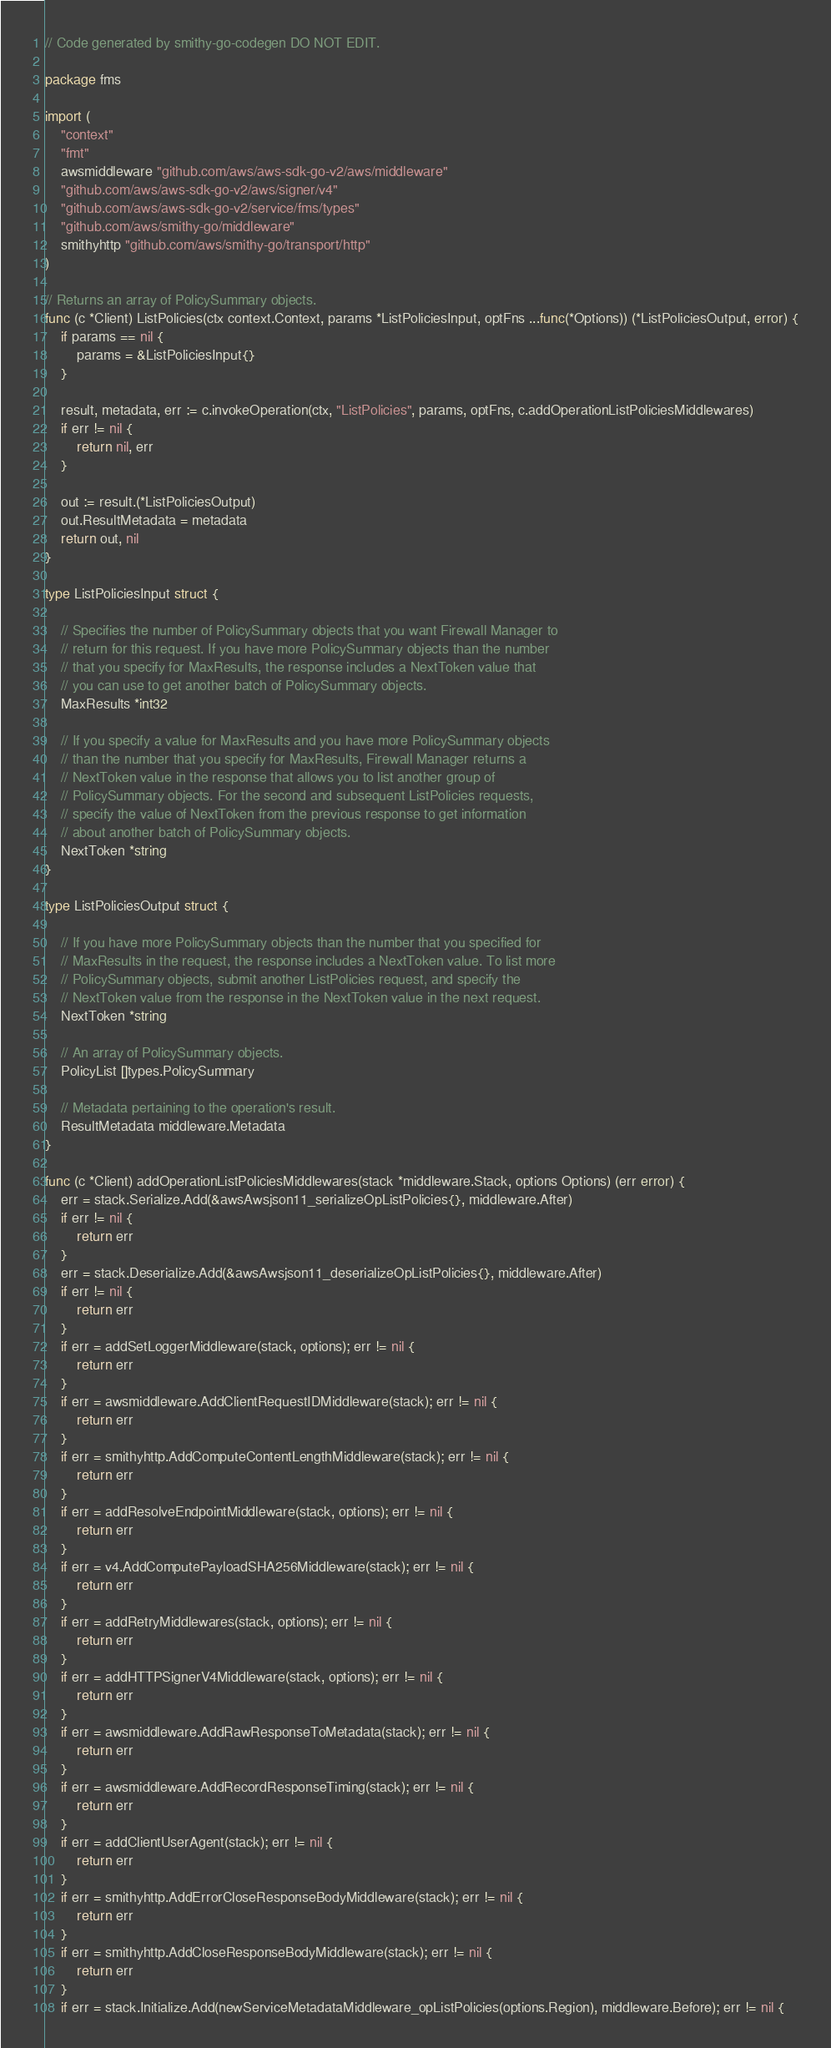<code> <loc_0><loc_0><loc_500><loc_500><_Go_>// Code generated by smithy-go-codegen DO NOT EDIT.

package fms

import (
	"context"
	"fmt"
	awsmiddleware "github.com/aws/aws-sdk-go-v2/aws/middleware"
	"github.com/aws/aws-sdk-go-v2/aws/signer/v4"
	"github.com/aws/aws-sdk-go-v2/service/fms/types"
	"github.com/aws/smithy-go/middleware"
	smithyhttp "github.com/aws/smithy-go/transport/http"
)

// Returns an array of PolicySummary objects.
func (c *Client) ListPolicies(ctx context.Context, params *ListPoliciesInput, optFns ...func(*Options)) (*ListPoliciesOutput, error) {
	if params == nil {
		params = &ListPoliciesInput{}
	}

	result, metadata, err := c.invokeOperation(ctx, "ListPolicies", params, optFns, c.addOperationListPoliciesMiddlewares)
	if err != nil {
		return nil, err
	}

	out := result.(*ListPoliciesOutput)
	out.ResultMetadata = metadata
	return out, nil
}

type ListPoliciesInput struct {

	// Specifies the number of PolicySummary objects that you want Firewall Manager to
	// return for this request. If you have more PolicySummary objects than the number
	// that you specify for MaxResults, the response includes a NextToken value that
	// you can use to get another batch of PolicySummary objects.
	MaxResults *int32

	// If you specify a value for MaxResults and you have more PolicySummary objects
	// than the number that you specify for MaxResults, Firewall Manager returns a
	// NextToken value in the response that allows you to list another group of
	// PolicySummary objects. For the second and subsequent ListPolicies requests,
	// specify the value of NextToken from the previous response to get information
	// about another batch of PolicySummary objects.
	NextToken *string
}

type ListPoliciesOutput struct {

	// If you have more PolicySummary objects than the number that you specified for
	// MaxResults in the request, the response includes a NextToken value. To list more
	// PolicySummary objects, submit another ListPolicies request, and specify the
	// NextToken value from the response in the NextToken value in the next request.
	NextToken *string

	// An array of PolicySummary objects.
	PolicyList []types.PolicySummary

	// Metadata pertaining to the operation's result.
	ResultMetadata middleware.Metadata
}

func (c *Client) addOperationListPoliciesMiddlewares(stack *middleware.Stack, options Options) (err error) {
	err = stack.Serialize.Add(&awsAwsjson11_serializeOpListPolicies{}, middleware.After)
	if err != nil {
		return err
	}
	err = stack.Deserialize.Add(&awsAwsjson11_deserializeOpListPolicies{}, middleware.After)
	if err != nil {
		return err
	}
	if err = addSetLoggerMiddleware(stack, options); err != nil {
		return err
	}
	if err = awsmiddleware.AddClientRequestIDMiddleware(stack); err != nil {
		return err
	}
	if err = smithyhttp.AddComputeContentLengthMiddleware(stack); err != nil {
		return err
	}
	if err = addResolveEndpointMiddleware(stack, options); err != nil {
		return err
	}
	if err = v4.AddComputePayloadSHA256Middleware(stack); err != nil {
		return err
	}
	if err = addRetryMiddlewares(stack, options); err != nil {
		return err
	}
	if err = addHTTPSignerV4Middleware(stack, options); err != nil {
		return err
	}
	if err = awsmiddleware.AddRawResponseToMetadata(stack); err != nil {
		return err
	}
	if err = awsmiddleware.AddRecordResponseTiming(stack); err != nil {
		return err
	}
	if err = addClientUserAgent(stack); err != nil {
		return err
	}
	if err = smithyhttp.AddErrorCloseResponseBodyMiddleware(stack); err != nil {
		return err
	}
	if err = smithyhttp.AddCloseResponseBodyMiddleware(stack); err != nil {
		return err
	}
	if err = stack.Initialize.Add(newServiceMetadataMiddleware_opListPolicies(options.Region), middleware.Before); err != nil {</code> 